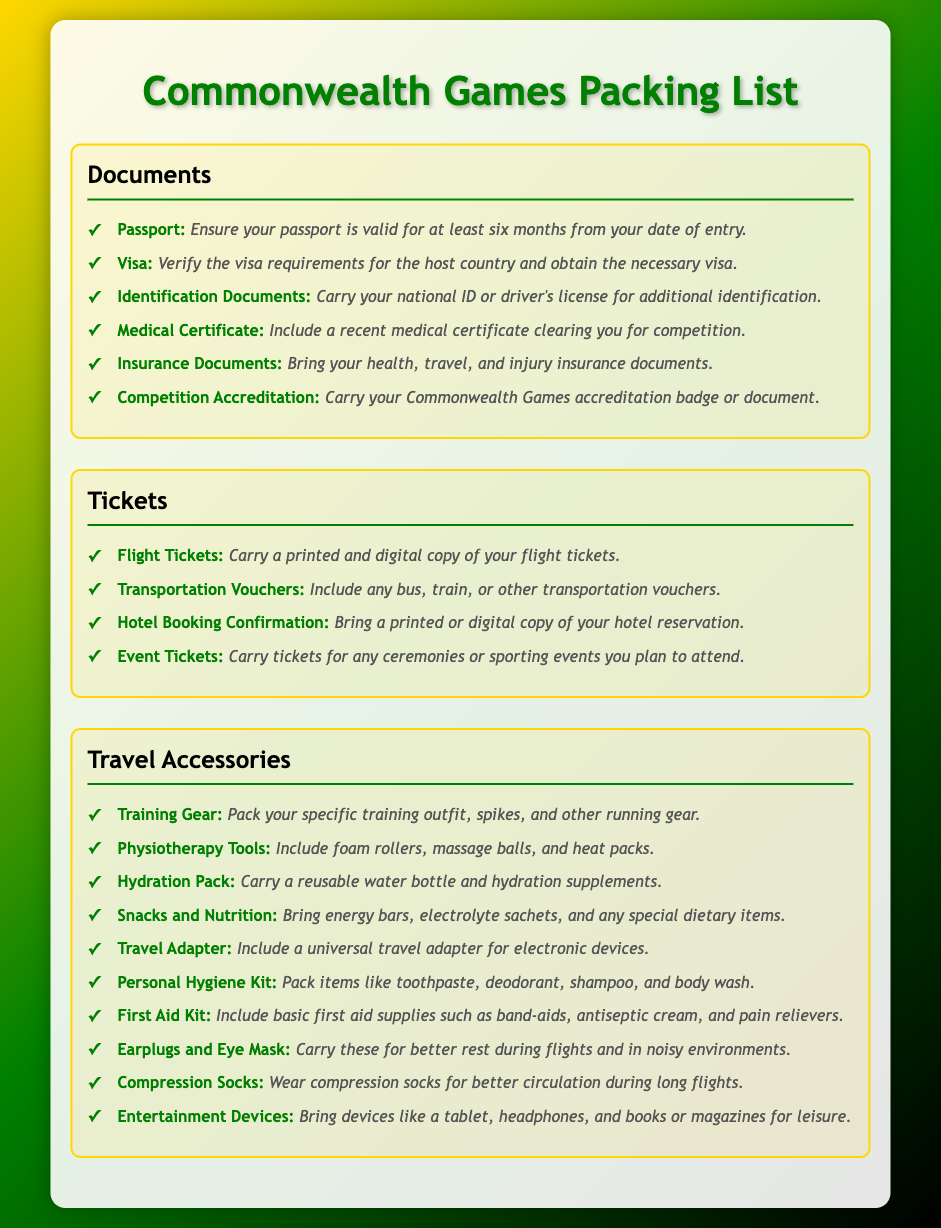what should you carry to clear competition? A recent medical certificate is required for clearing competition.
Answer: Medical Certificate how many types of tickets should you carry? There are four mentioned types of tickets in the packing list.
Answer: Four which document shows you have permission to compete? The competition accreditation document is essential for this purpose.
Answer: Competition Accreditation what is included in the Travel Accessories section? The Travel Accessories section contains multiple items essential for travel, including training gear and first aid kit.
Answer: Training Gear which item helps with hydration? A reusable water bottle is included for hydration purposes.
Answer: Hydration Pack what are compression socks used for? Compression socks are used for better circulation during long flights.
Answer: Better circulation what is the purpose of the insurance documents? Insurance documents provide health, travel, and injury coverage for athletes.
Answer: Health, travel, and injury insurance how long should your passport be valid? The passport should be valid for at least six months from the date of entry.
Answer: Six months what is advised to bring for entertainment? Devices like a tablet and headphones are recommended for leisure.
Answer: Entertainment Devices 